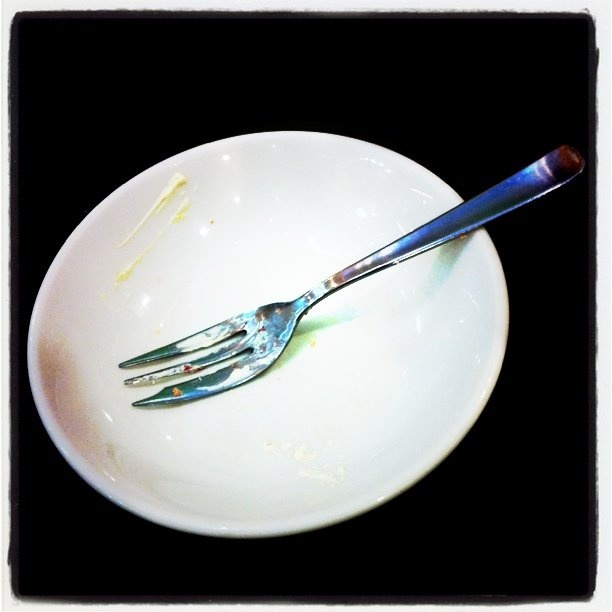Describe the objects in this image and their specific colors. I can see bowl in white, darkgray, and beige tones and fork in white, black, gray, and blue tones in this image. 